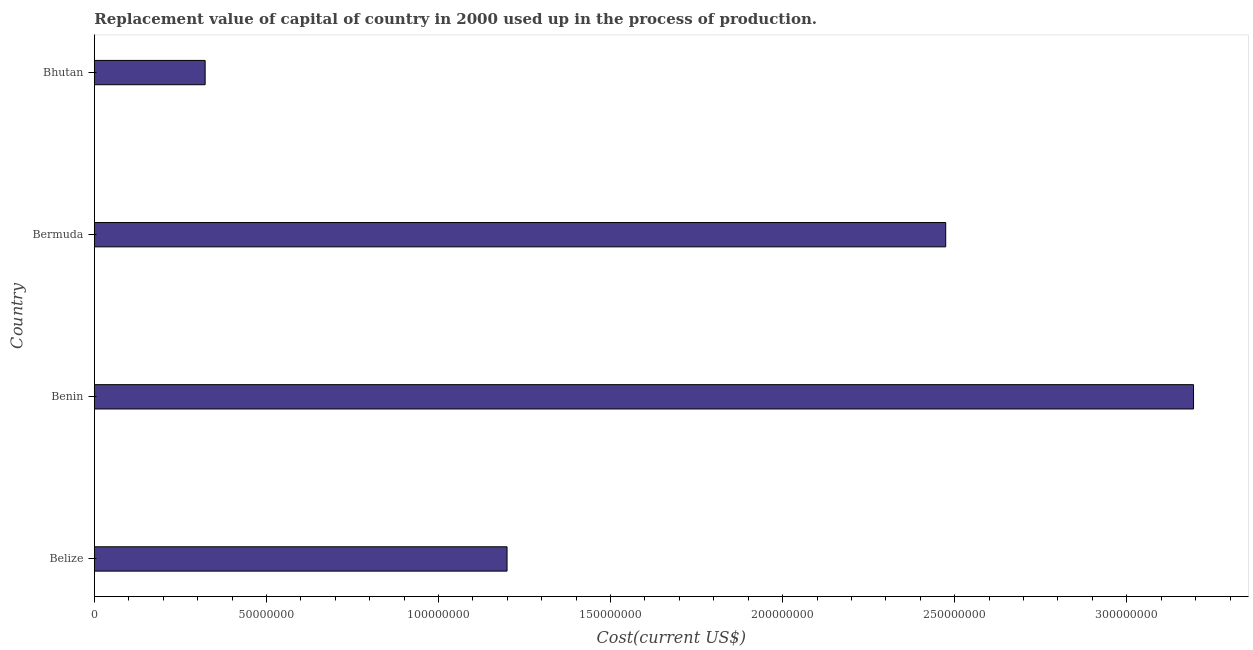Does the graph contain any zero values?
Your response must be concise. No. Does the graph contain grids?
Provide a short and direct response. No. What is the title of the graph?
Offer a very short reply. Replacement value of capital of country in 2000 used up in the process of production. What is the label or title of the X-axis?
Your response must be concise. Cost(current US$). What is the label or title of the Y-axis?
Provide a short and direct response. Country. What is the consumption of fixed capital in Belize?
Provide a short and direct response. 1.20e+08. Across all countries, what is the maximum consumption of fixed capital?
Offer a very short reply. 3.19e+08. Across all countries, what is the minimum consumption of fixed capital?
Your response must be concise. 3.22e+07. In which country was the consumption of fixed capital maximum?
Offer a terse response. Benin. In which country was the consumption of fixed capital minimum?
Your response must be concise. Bhutan. What is the sum of the consumption of fixed capital?
Offer a very short reply. 7.19e+08. What is the difference between the consumption of fixed capital in Bermuda and Bhutan?
Your response must be concise. 2.15e+08. What is the average consumption of fixed capital per country?
Give a very brief answer. 1.80e+08. What is the median consumption of fixed capital?
Offer a very short reply. 1.84e+08. What is the ratio of the consumption of fixed capital in Benin to that in Bhutan?
Ensure brevity in your answer.  9.92. Is the difference between the consumption of fixed capital in Benin and Bhutan greater than the difference between any two countries?
Provide a succinct answer. Yes. What is the difference between the highest and the second highest consumption of fixed capital?
Offer a very short reply. 7.20e+07. What is the difference between the highest and the lowest consumption of fixed capital?
Offer a very short reply. 2.87e+08. In how many countries, is the consumption of fixed capital greater than the average consumption of fixed capital taken over all countries?
Give a very brief answer. 2. Are all the bars in the graph horizontal?
Your answer should be very brief. Yes. How many countries are there in the graph?
Provide a succinct answer. 4. What is the Cost(current US$) of Belize?
Give a very brief answer. 1.20e+08. What is the Cost(current US$) in Benin?
Offer a terse response. 3.19e+08. What is the Cost(current US$) in Bermuda?
Offer a terse response. 2.47e+08. What is the Cost(current US$) in Bhutan?
Offer a very short reply. 3.22e+07. What is the difference between the Cost(current US$) in Belize and Benin?
Your answer should be very brief. -1.99e+08. What is the difference between the Cost(current US$) in Belize and Bermuda?
Your answer should be very brief. -1.27e+08. What is the difference between the Cost(current US$) in Belize and Bhutan?
Your answer should be very brief. 8.77e+07. What is the difference between the Cost(current US$) in Benin and Bermuda?
Offer a very short reply. 7.20e+07. What is the difference between the Cost(current US$) in Benin and Bhutan?
Give a very brief answer. 2.87e+08. What is the difference between the Cost(current US$) in Bermuda and Bhutan?
Ensure brevity in your answer.  2.15e+08. What is the ratio of the Cost(current US$) in Belize to that in Benin?
Make the answer very short. 0.38. What is the ratio of the Cost(current US$) in Belize to that in Bermuda?
Ensure brevity in your answer.  0.48. What is the ratio of the Cost(current US$) in Belize to that in Bhutan?
Make the answer very short. 3.73. What is the ratio of the Cost(current US$) in Benin to that in Bermuda?
Provide a succinct answer. 1.29. What is the ratio of the Cost(current US$) in Benin to that in Bhutan?
Your answer should be very brief. 9.92. What is the ratio of the Cost(current US$) in Bermuda to that in Bhutan?
Your response must be concise. 7.68. 